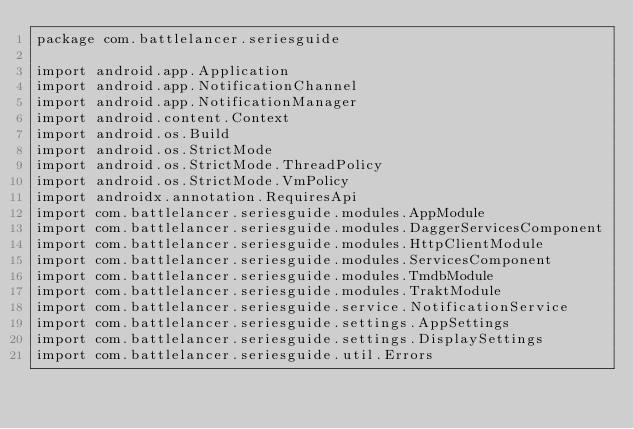Convert code to text. <code><loc_0><loc_0><loc_500><loc_500><_Kotlin_>package com.battlelancer.seriesguide

import android.app.Application
import android.app.NotificationChannel
import android.app.NotificationManager
import android.content.Context
import android.os.Build
import android.os.StrictMode
import android.os.StrictMode.ThreadPolicy
import android.os.StrictMode.VmPolicy
import androidx.annotation.RequiresApi
import com.battlelancer.seriesguide.modules.AppModule
import com.battlelancer.seriesguide.modules.DaggerServicesComponent
import com.battlelancer.seriesguide.modules.HttpClientModule
import com.battlelancer.seriesguide.modules.ServicesComponent
import com.battlelancer.seriesguide.modules.TmdbModule
import com.battlelancer.seriesguide.modules.TraktModule
import com.battlelancer.seriesguide.service.NotificationService
import com.battlelancer.seriesguide.settings.AppSettings
import com.battlelancer.seriesguide.settings.DisplaySettings
import com.battlelancer.seriesguide.util.Errors</code> 